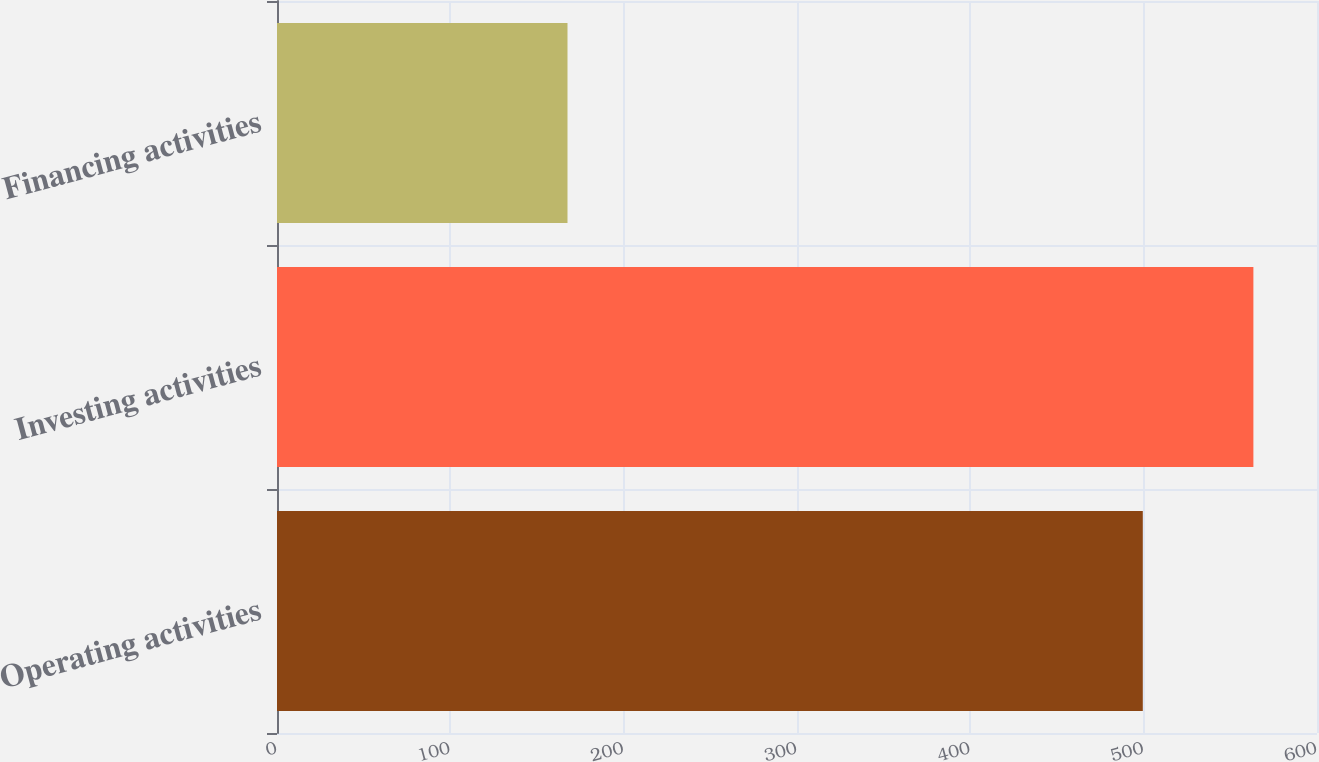Convert chart. <chart><loc_0><loc_0><loc_500><loc_500><bar_chart><fcel>Operating activities<fcel>Investing activities<fcel>Financing activities<nl><fcel>499.5<fcel>563.3<fcel>167.6<nl></chart> 